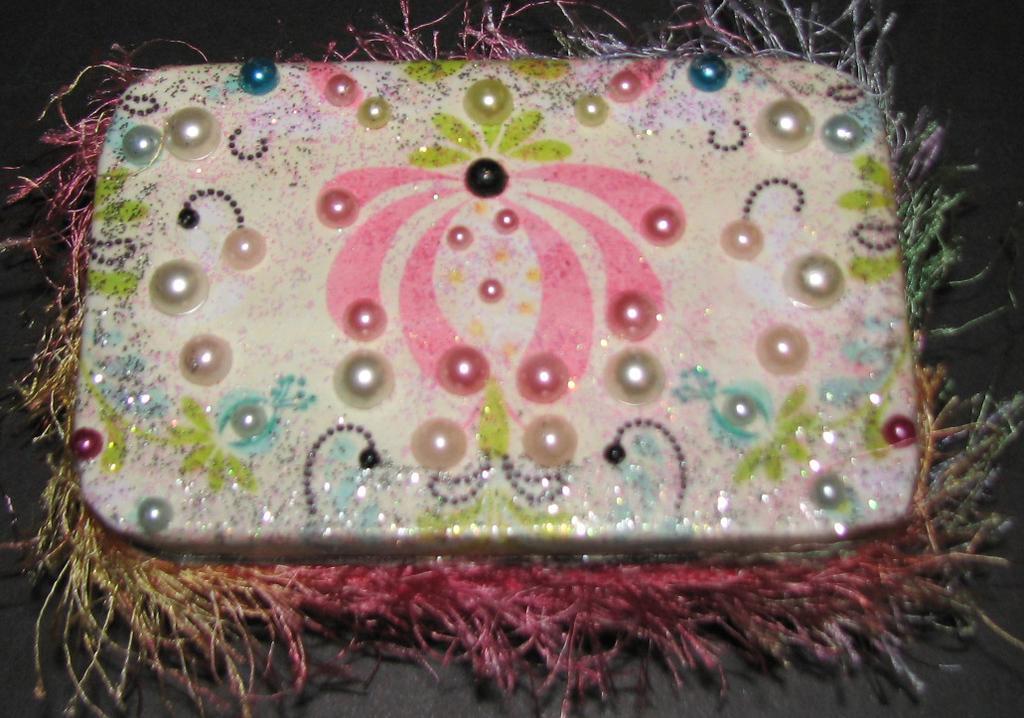How would you summarize this image in a sentence or two? In this image I can see the colorful object and few colorful pearls. Background is in black color. 